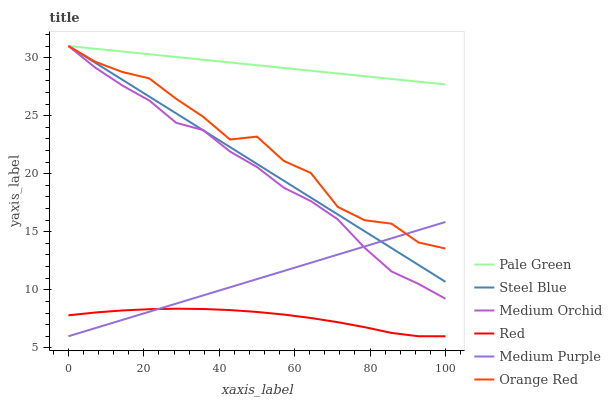Does Red have the minimum area under the curve?
Answer yes or no. Yes. Does Pale Green have the maximum area under the curve?
Answer yes or no. Yes. Does Steel Blue have the minimum area under the curve?
Answer yes or no. No. Does Steel Blue have the maximum area under the curve?
Answer yes or no. No. Is Medium Purple the smoothest?
Answer yes or no. Yes. Is Orange Red the roughest?
Answer yes or no. Yes. Is Steel Blue the smoothest?
Answer yes or no. No. Is Steel Blue the roughest?
Answer yes or no. No. Does Medium Purple have the lowest value?
Answer yes or no. Yes. Does Steel Blue have the lowest value?
Answer yes or no. No. Does Orange Red have the highest value?
Answer yes or no. Yes. Does Medium Purple have the highest value?
Answer yes or no. No. Is Medium Purple less than Pale Green?
Answer yes or no. Yes. Is Steel Blue greater than Red?
Answer yes or no. Yes. Does Medium Orchid intersect Medium Purple?
Answer yes or no. Yes. Is Medium Orchid less than Medium Purple?
Answer yes or no. No. Is Medium Orchid greater than Medium Purple?
Answer yes or no. No. Does Medium Purple intersect Pale Green?
Answer yes or no. No. 